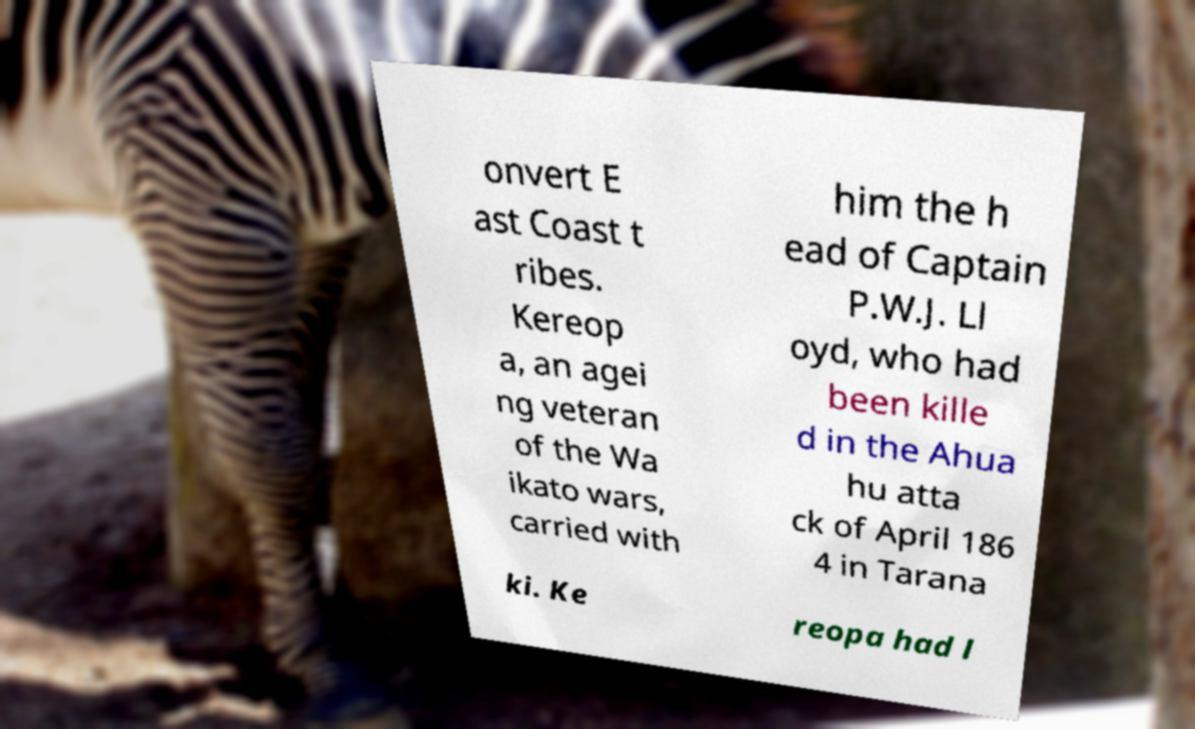For documentation purposes, I need the text within this image transcribed. Could you provide that? onvert E ast Coast t ribes. Kereop a, an agei ng veteran of the Wa ikato wars, carried with him the h ead of Captain P.W.J. Ll oyd, who had been kille d in the Ahua hu atta ck of April 186 4 in Tarana ki. Ke reopa had l 